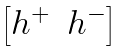Convert formula to latex. <formula><loc_0><loc_0><loc_500><loc_500>\begin{bmatrix} h ^ { + } & h ^ { - } \end{bmatrix}</formula> 